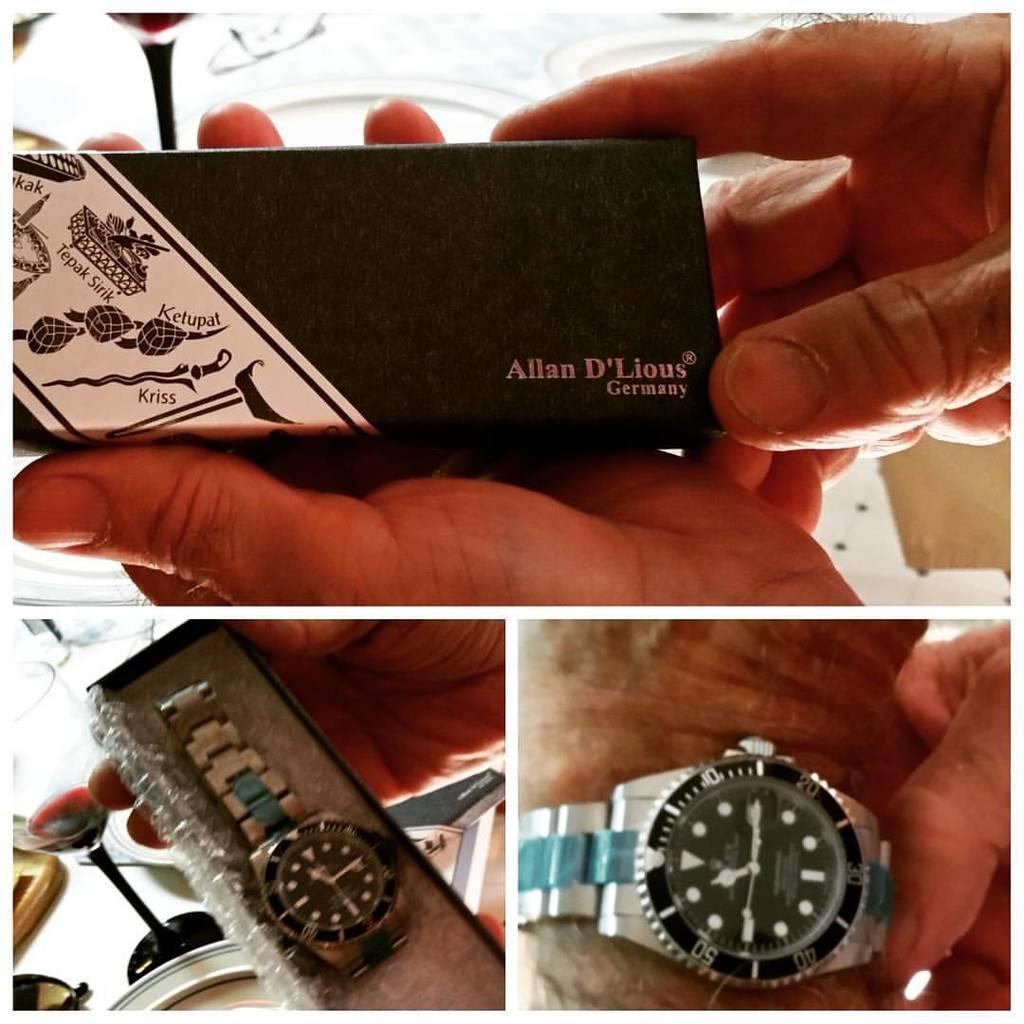What brand is the watch?
Your answer should be very brief. Allan d'lious. What company is the watch from?
Ensure brevity in your answer.  Allan d'lious. 